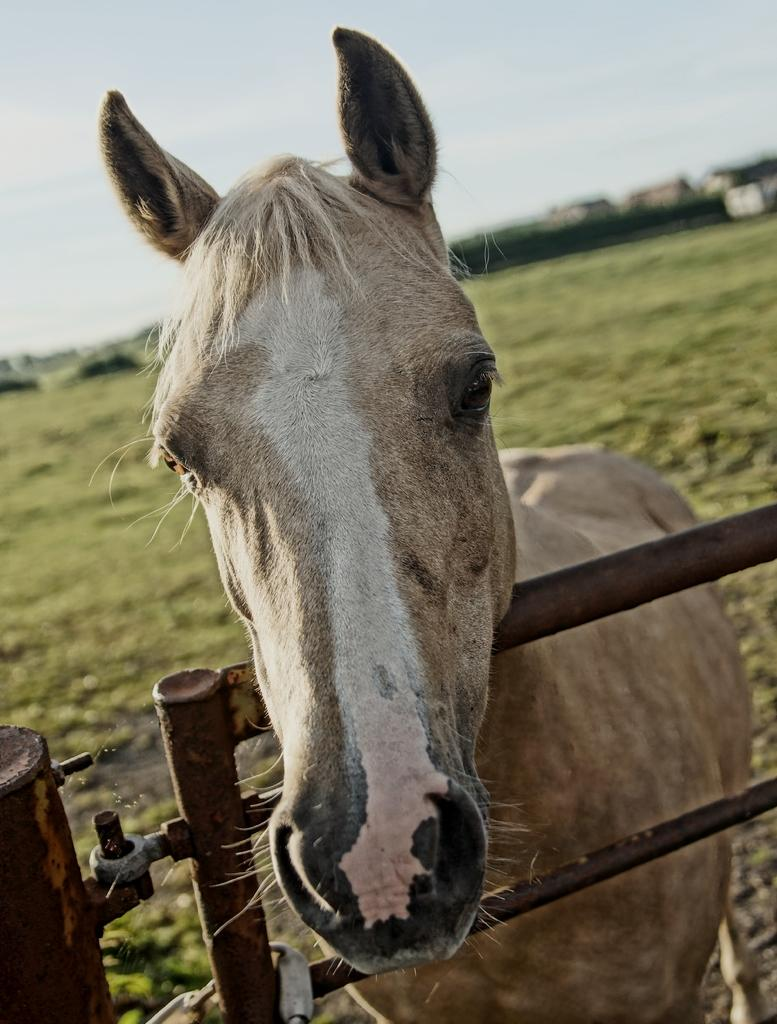What animal is present in the image? There is a horse in the image. Where is the horse located in relation to the fence? The horse is standing at a fence. What type of vegetation can be seen in the background of the image? There is grass visible in the background of the image. What structures are visible in the background of the image? There are houses in the background of the image. What part of the natural environment is visible in the image? The sky is visible in the background of the image. What type of mitten is the horse wearing in the image? There is no mitten present in the image, and horses do not wear mittens. Where is the shop located in the image? There is no shop present in the image. 